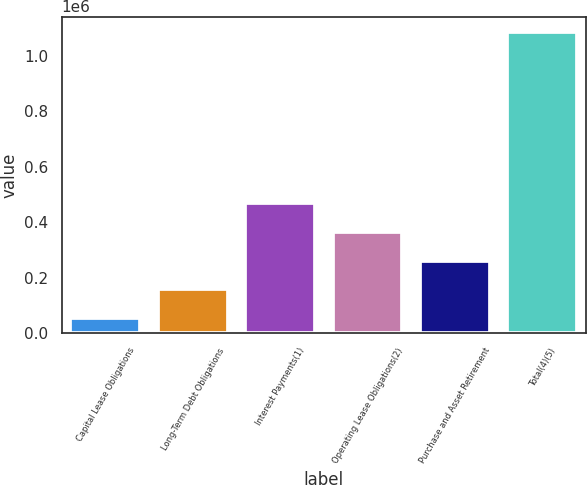Convert chart to OTSL. <chart><loc_0><loc_0><loc_500><loc_500><bar_chart><fcel>Capital Lease Obligations<fcel>Long-Term Debt Obligations<fcel>Interest Payments(1)<fcel>Operating Lease Obligations(2)<fcel>Purchase and Asset Retirement<fcel>Total(4)(5)<nl><fcel>54566<fcel>157884<fcel>467837<fcel>364519<fcel>261201<fcel>1.08774e+06<nl></chart> 